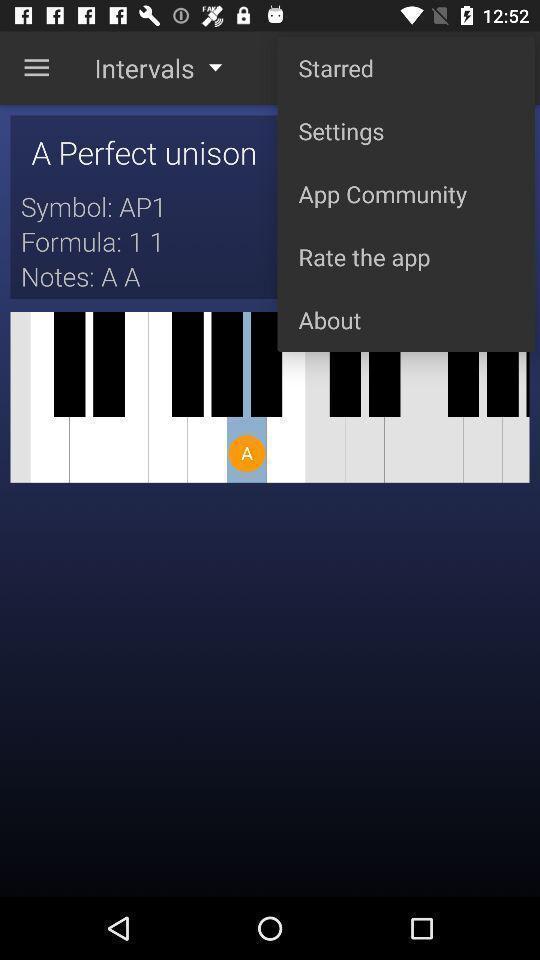Tell me about the visual elements in this screen capture. Pop up showing different options in app. 